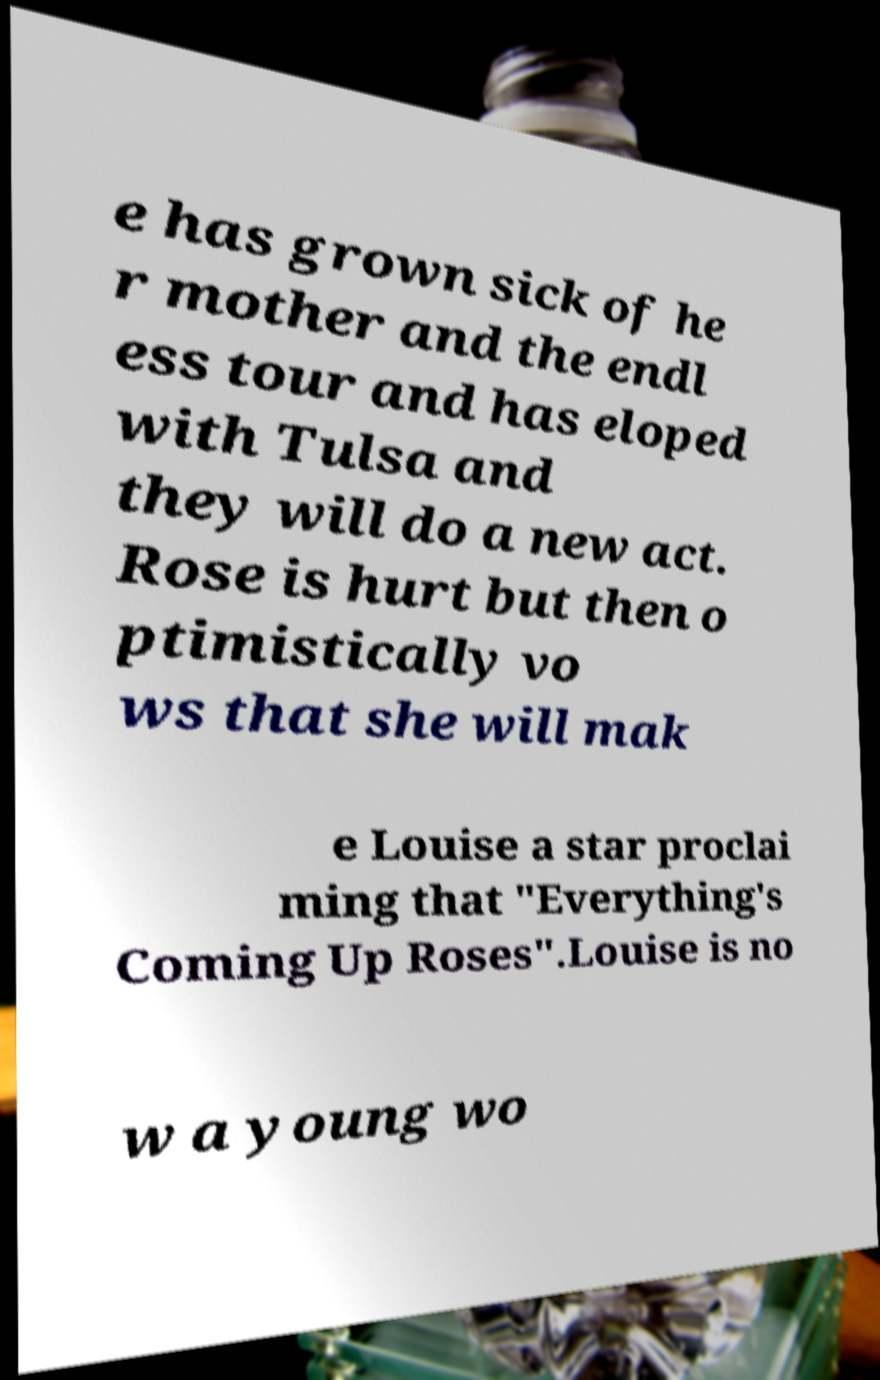Can you accurately transcribe the text from the provided image for me? e has grown sick of he r mother and the endl ess tour and has eloped with Tulsa and they will do a new act. Rose is hurt but then o ptimistically vo ws that she will mak e Louise a star proclai ming that "Everything's Coming Up Roses".Louise is no w a young wo 